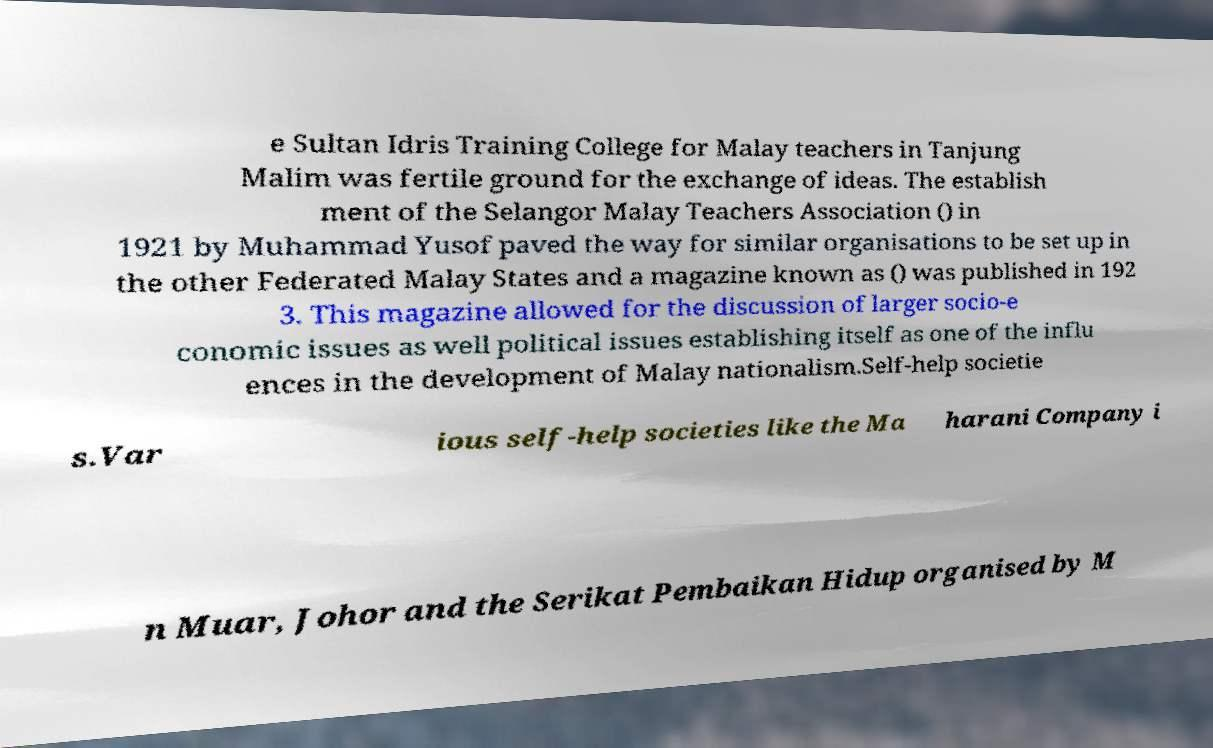Can you accurately transcribe the text from the provided image for me? e Sultan Idris Training College for Malay teachers in Tanjung Malim was fertile ground for the exchange of ideas. The establish ment of the Selangor Malay Teachers Association () in 1921 by Muhammad Yusof paved the way for similar organisations to be set up in the other Federated Malay States and a magazine known as () was published in 192 3. This magazine allowed for the discussion of larger socio-e conomic issues as well political issues establishing itself as one of the influ ences in the development of Malay nationalism.Self-help societie s.Var ious self-help societies like the Ma harani Company i n Muar, Johor and the Serikat Pembaikan Hidup organised by M 